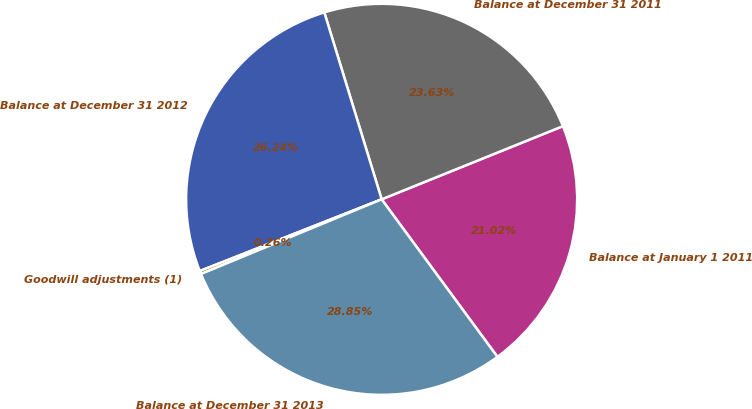<chart> <loc_0><loc_0><loc_500><loc_500><pie_chart><fcel>Balance at January 1 2011<fcel>Balance at December 31 2011<fcel>Balance at December 31 2012<fcel>Goodwill adjustments (1)<fcel>Balance at December 31 2013<nl><fcel>21.02%<fcel>23.63%<fcel>26.24%<fcel>0.26%<fcel>28.85%<nl></chart> 